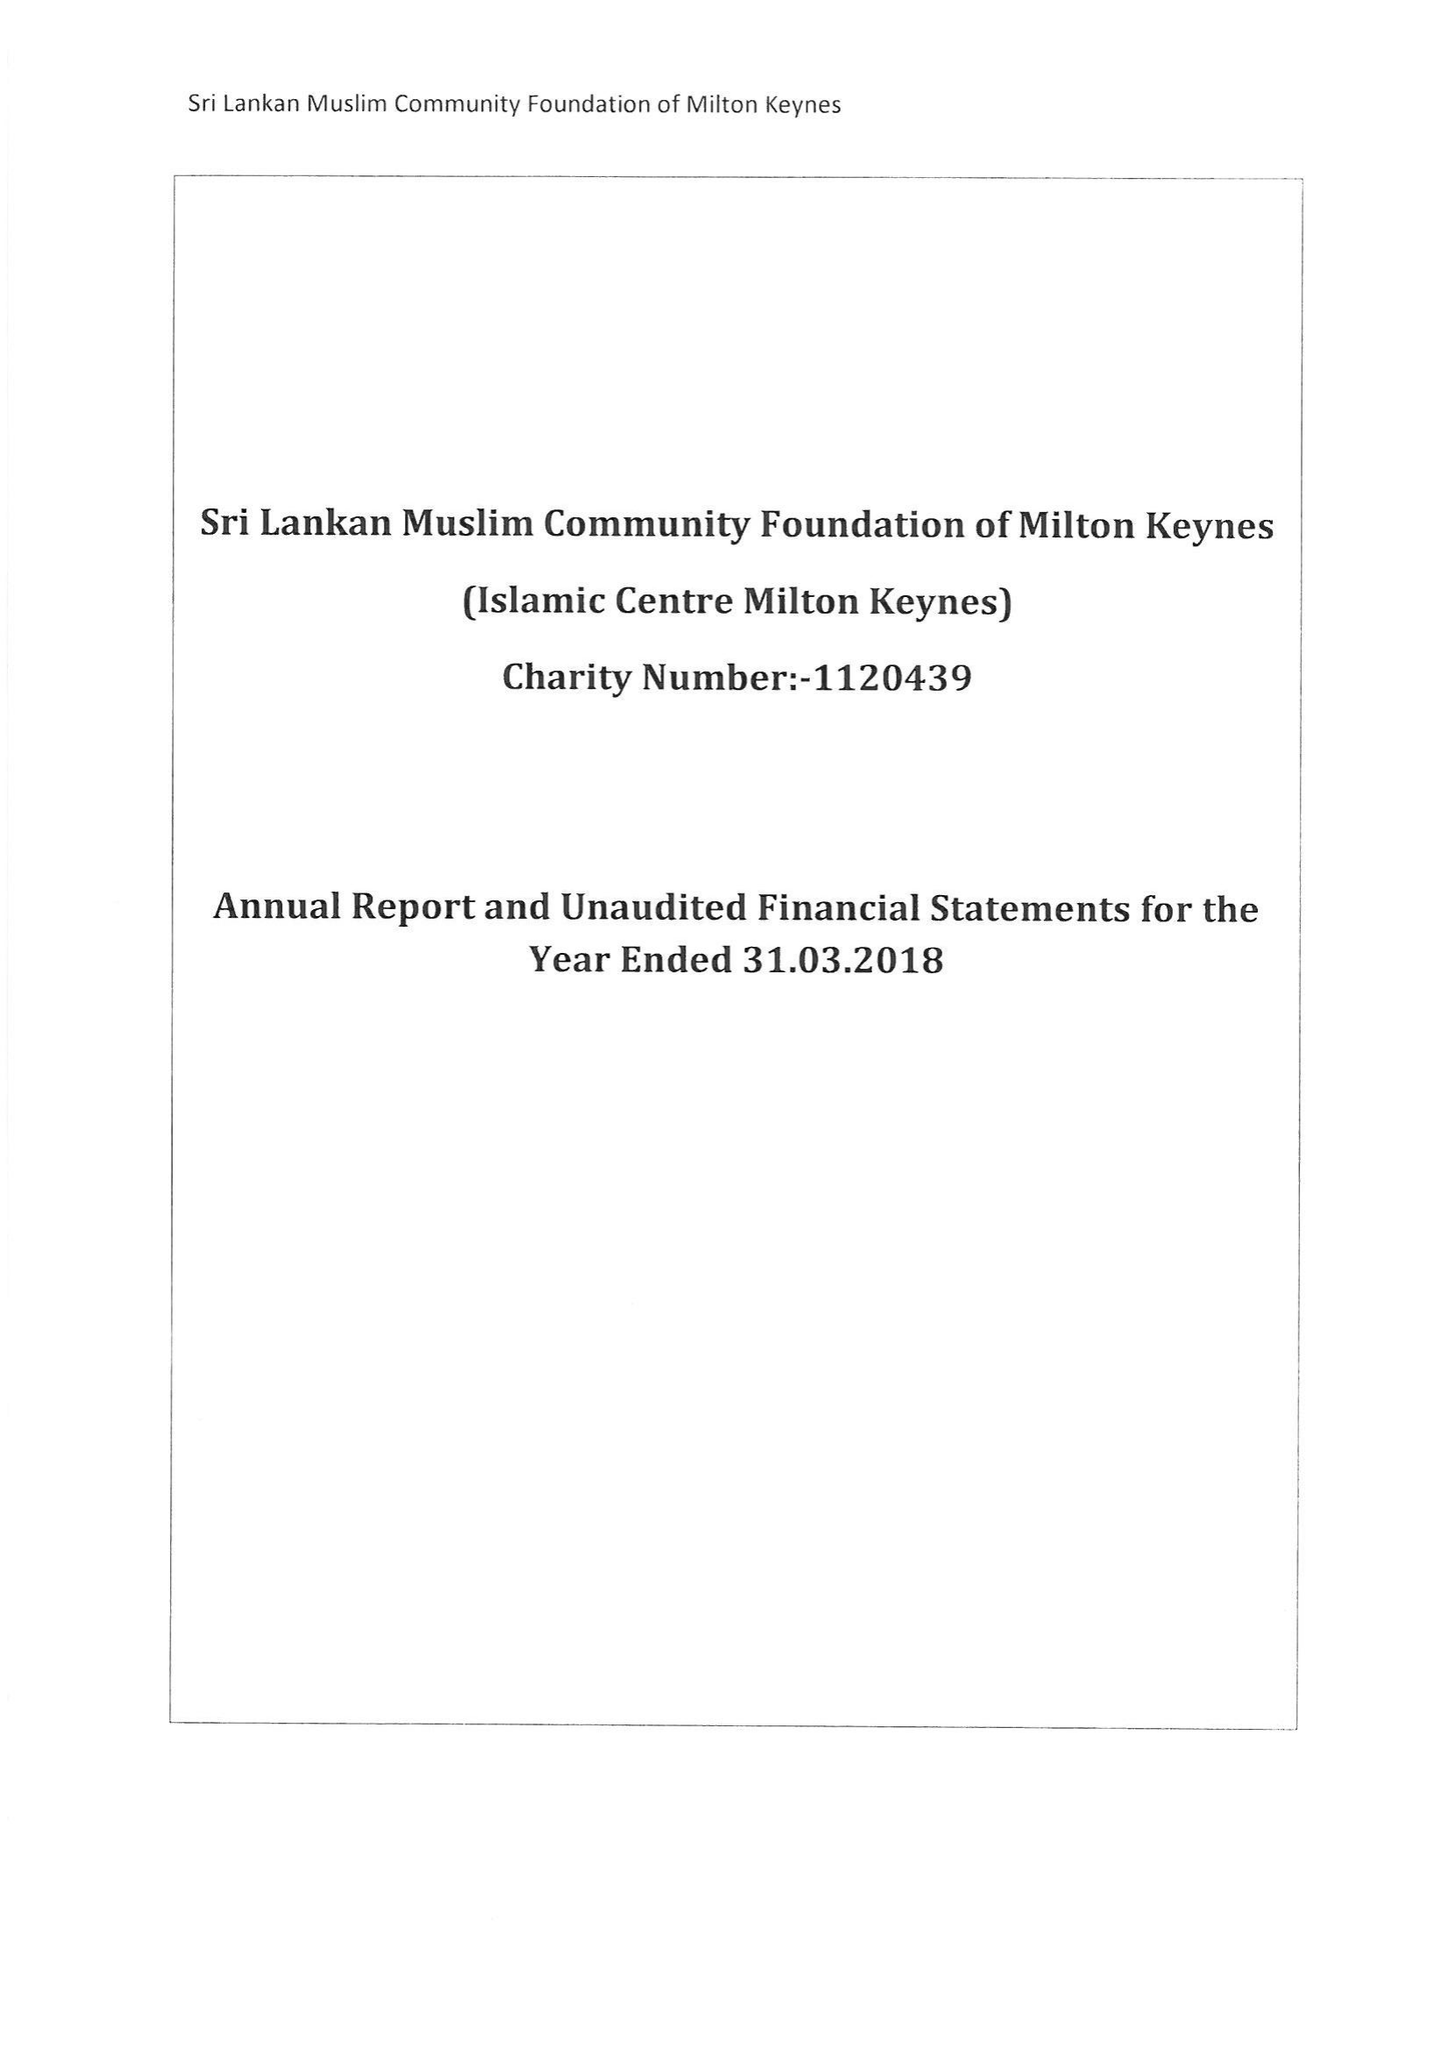What is the value for the income_annually_in_british_pounds?
Answer the question using a single word or phrase. 113631.00 